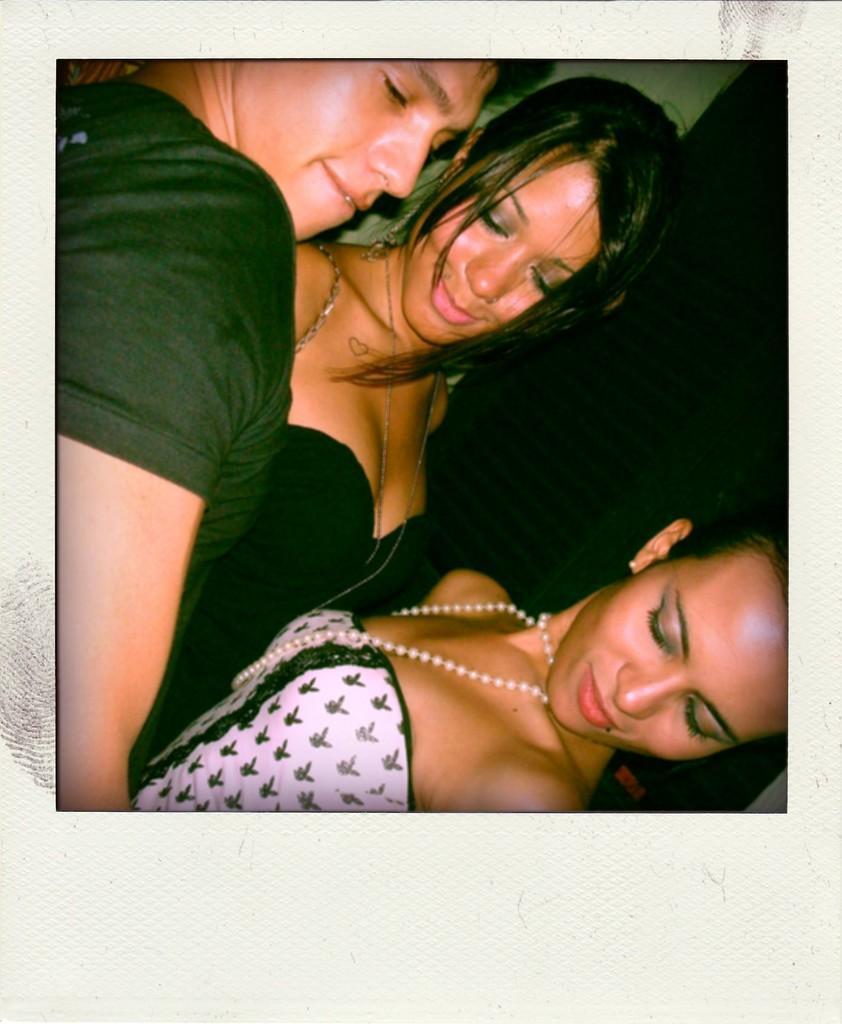Please provide a concise description of this image. In this image this is the photography of group of people and they are having black hair. 